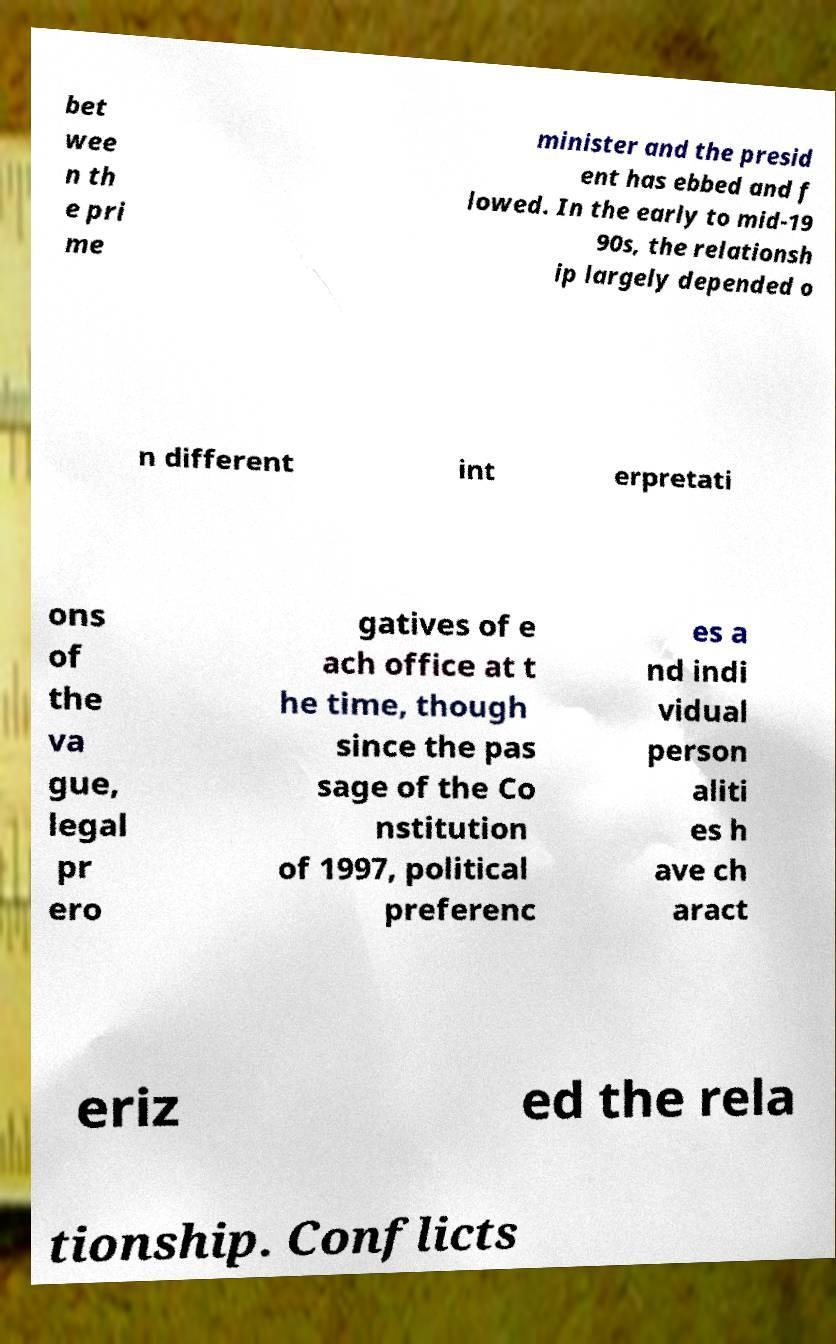Could you extract and type out the text from this image? bet wee n th e pri me minister and the presid ent has ebbed and f lowed. In the early to mid-19 90s, the relationsh ip largely depended o n different int erpretati ons of the va gue, legal pr ero gatives of e ach office at t he time, though since the pas sage of the Co nstitution of 1997, political preferenc es a nd indi vidual person aliti es h ave ch aract eriz ed the rela tionship. Conflicts 